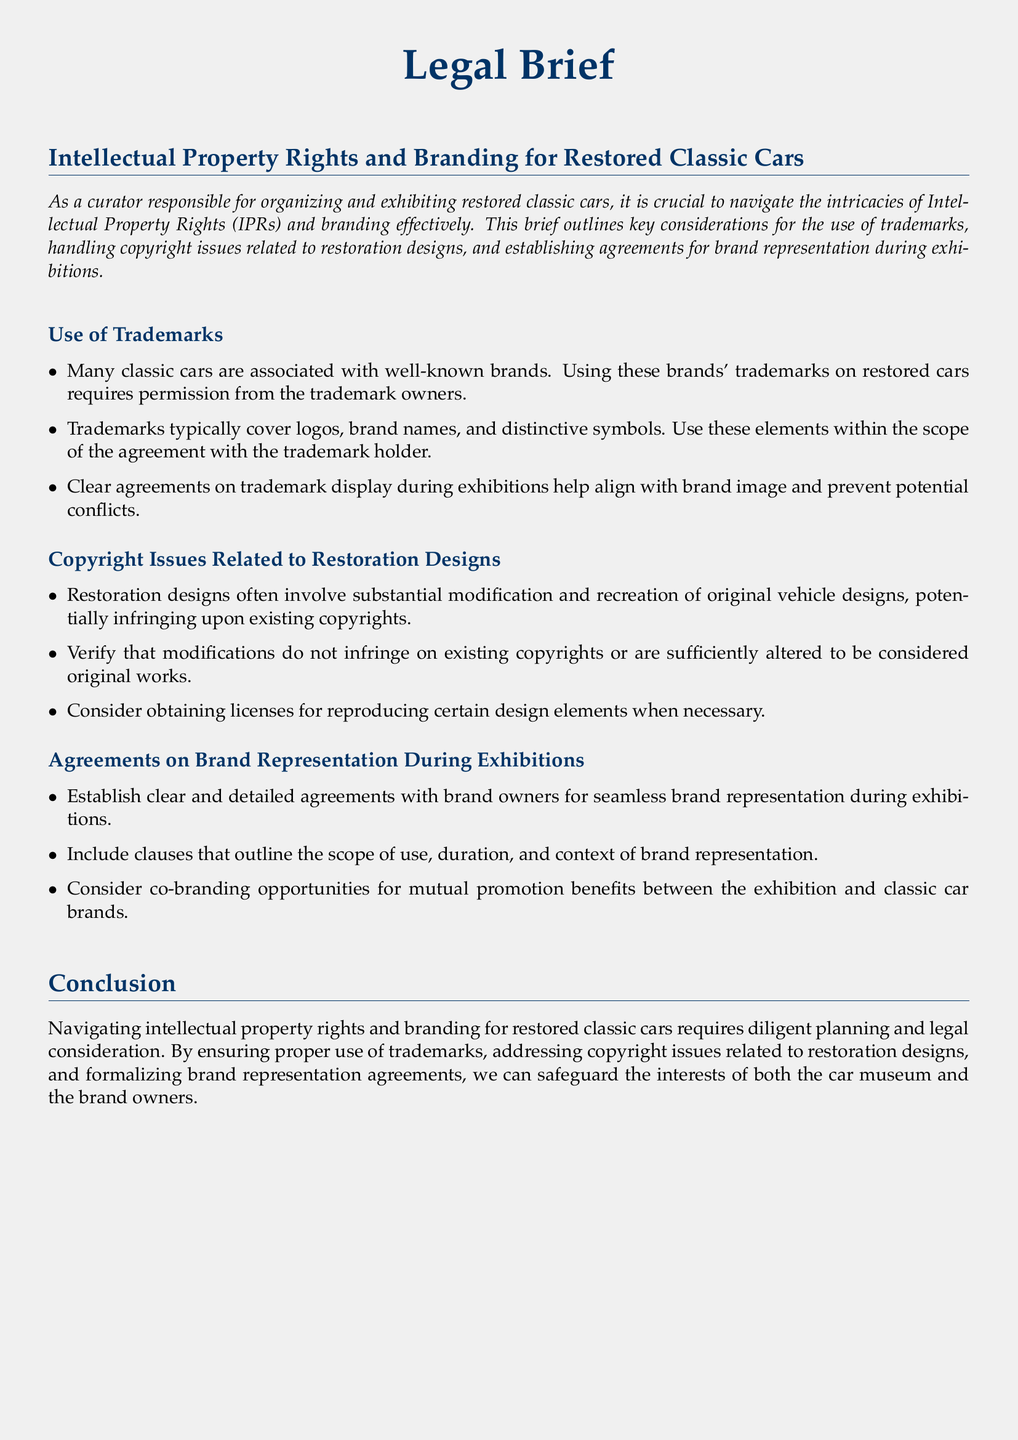What are the key considerations for intellectual property rights in classic car exhibitions? The key considerations include the use of trademarks, handling copyright issues related to restoration designs, and establishing agreements for brand representation during exhibitions.
Answer: trademarks, copyright issues, agreements What must be obtained to use trademarks associated with classic cars? Permission from the trademark owners must be obtained to use their trademarks on restored cars.
Answer: permission What is necessary to verify regarding modifications to classic car designs? It is necessary to verify that modifications do not infringe on existing copyrights or are sufficiently altered to be considered original works.
Answer: original works What should agreements on brand representation during exhibitions outline? Agreements should outline the scope of use, duration, and context of brand representation.
Answer: scope of use, duration, context What type of opportunities should be considered for mutual promotion? Co-branding opportunities should be considered for mutual promotion benefits between the exhibition and classic car brands.
Answer: co-branding opportunities What is a potential consequence of not addressing copyright issues in restoration designs? A potential consequence is infringing upon existing copyrights.
Answer: infringing copyrights How can brand owners benefit from clear representation agreements? Clear representation agreements can help ensure seamless brand representation during exhibitions.
Answer: seamless representation What should be done if certain design elements need to be reproduced? Consider obtaining licenses for reproducing certain design elements when necessary.
Answer: obtaining licenses 